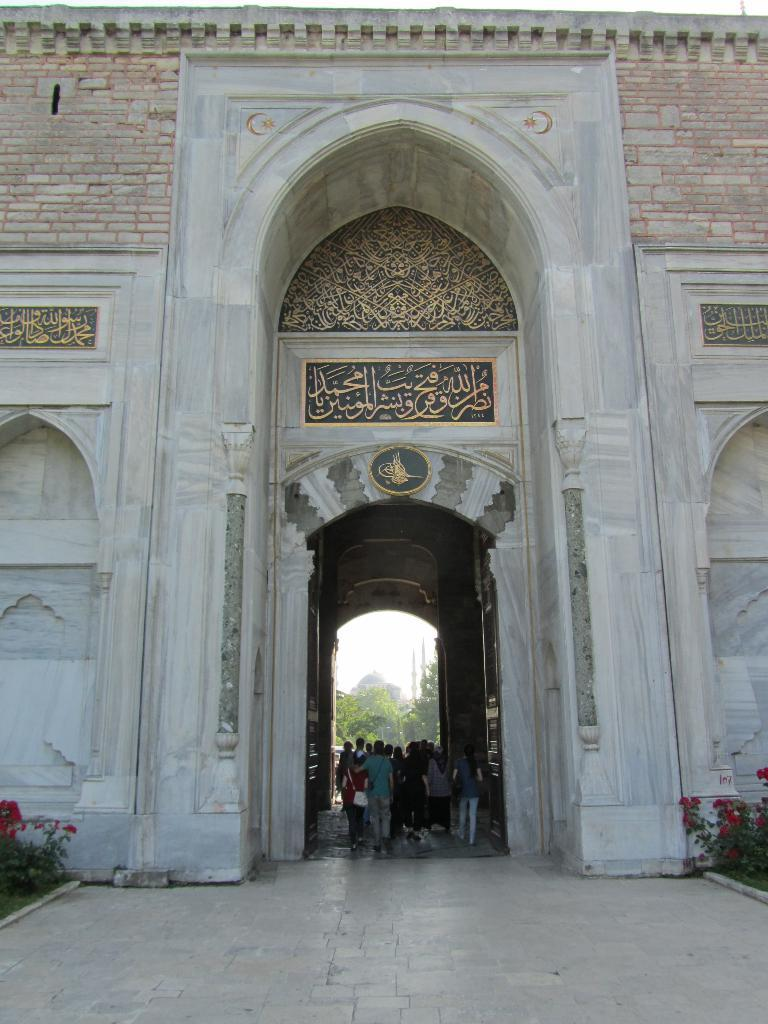What type of structure is visible in the image? There is a building in the image. What can be seen on the wall of the building? There are carvings on the wall of the building. Are there any people present in the image? Yes, there are people standing in the image. What type of vegetation can be seen in the image? There are plants with flowers in the image. How many flies can be seen on the carvings in the image? There are no flies present in the image; it only features a building with carvings, people, and plants with flowers. 